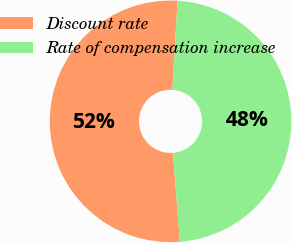Convert chart to OTSL. <chart><loc_0><loc_0><loc_500><loc_500><pie_chart><fcel>Discount rate<fcel>Rate of compensation increase<nl><fcel>52.15%<fcel>47.85%<nl></chart> 